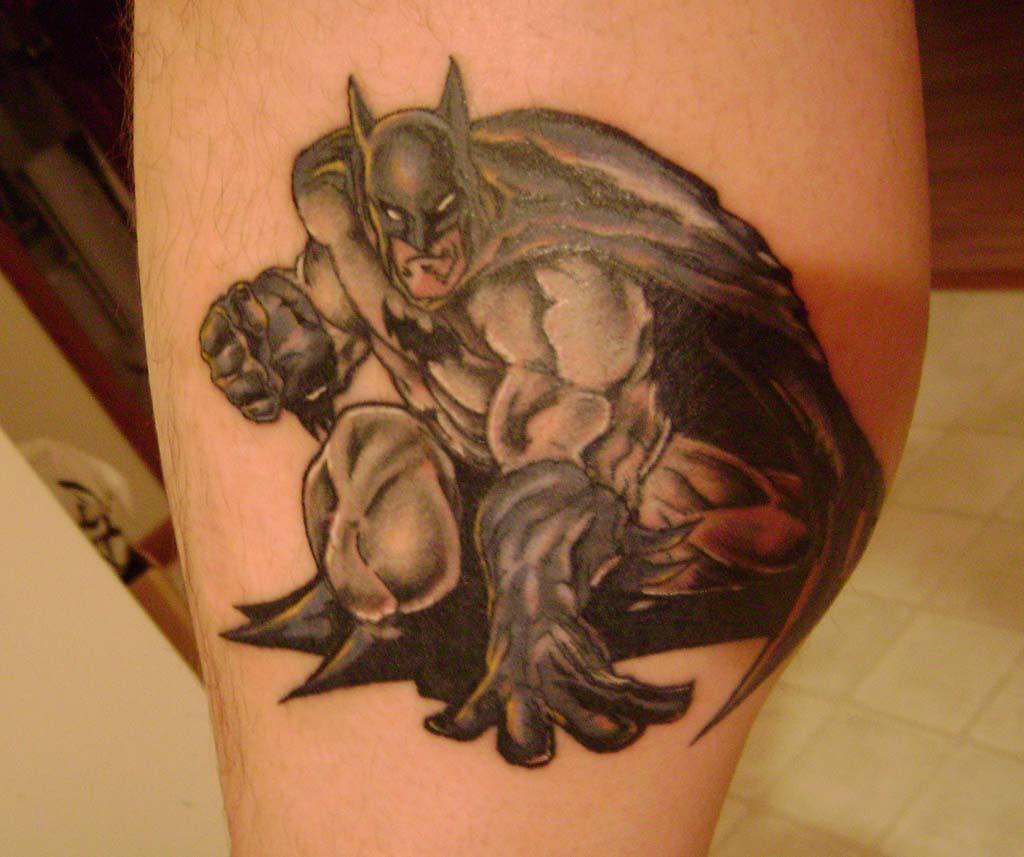How would you summarize this image in a sentence or two? In this image we can see a batman tattoo on a person's body part. 